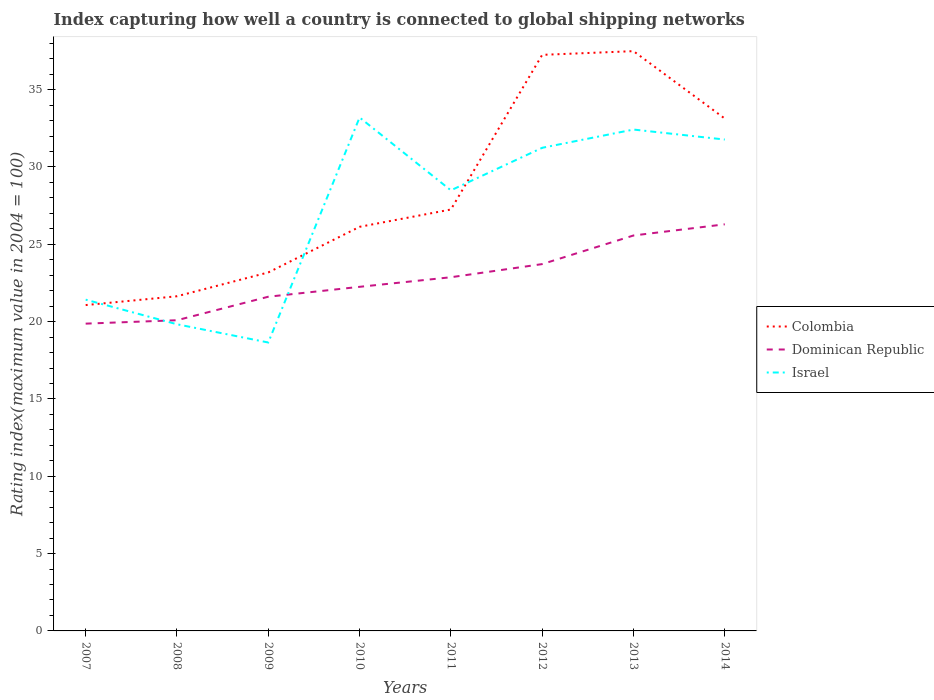Does the line corresponding to Dominican Republic intersect with the line corresponding to Israel?
Your answer should be compact. Yes. Across all years, what is the maximum rating index in Dominican Republic?
Offer a very short reply. 19.87. What is the total rating index in Israel in the graph?
Make the answer very short. -3.28. What is the difference between the highest and the second highest rating index in Dominican Republic?
Keep it short and to the point. 6.42. How many lines are there?
Your response must be concise. 3. How many years are there in the graph?
Your response must be concise. 8. How many legend labels are there?
Provide a short and direct response. 3. What is the title of the graph?
Offer a terse response. Index capturing how well a country is connected to global shipping networks. Does "Angola" appear as one of the legend labels in the graph?
Make the answer very short. No. What is the label or title of the Y-axis?
Provide a short and direct response. Rating index(maximum value in 2004 = 100). What is the Rating index(maximum value in 2004 = 100) in Colombia in 2007?
Ensure brevity in your answer.  21.07. What is the Rating index(maximum value in 2004 = 100) in Dominican Republic in 2007?
Offer a very short reply. 19.87. What is the Rating index(maximum value in 2004 = 100) in Israel in 2007?
Ensure brevity in your answer.  21.42. What is the Rating index(maximum value in 2004 = 100) of Colombia in 2008?
Give a very brief answer. 21.64. What is the Rating index(maximum value in 2004 = 100) in Dominican Republic in 2008?
Your answer should be compact. 20.09. What is the Rating index(maximum value in 2004 = 100) of Israel in 2008?
Offer a very short reply. 19.83. What is the Rating index(maximum value in 2004 = 100) of Colombia in 2009?
Offer a very short reply. 23.18. What is the Rating index(maximum value in 2004 = 100) in Dominican Republic in 2009?
Provide a succinct answer. 21.61. What is the Rating index(maximum value in 2004 = 100) in Israel in 2009?
Provide a short and direct response. 18.65. What is the Rating index(maximum value in 2004 = 100) in Colombia in 2010?
Provide a succinct answer. 26.13. What is the Rating index(maximum value in 2004 = 100) of Dominican Republic in 2010?
Provide a succinct answer. 22.25. What is the Rating index(maximum value in 2004 = 100) in Israel in 2010?
Make the answer very short. 33.2. What is the Rating index(maximum value in 2004 = 100) in Colombia in 2011?
Offer a terse response. 27.25. What is the Rating index(maximum value in 2004 = 100) of Dominican Republic in 2011?
Your answer should be compact. 22.87. What is the Rating index(maximum value in 2004 = 100) of Israel in 2011?
Your answer should be very brief. 28.49. What is the Rating index(maximum value in 2004 = 100) of Colombia in 2012?
Your answer should be very brief. 37.25. What is the Rating index(maximum value in 2004 = 100) in Dominican Republic in 2012?
Keep it short and to the point. 23.72. What is the Rating index(maximum value in 2004 = 100) of Israel in 2012?
Provide a short and direct response. 31.24. What is the Rating index(maximum value in 2004 = 100) of Colombia in 2013?
Provide a succinct answer. 37.49. What is the Rating index(maximum value in 2004 = 100) of Dominican Republic in 2013?
Ensure brevity in your answer.  25.57. What is the Rating index(maximum value in 2004 = 100) in Israel in 2013?
Provide a succinct answer. 32.42. What is the Rating index(maximum value in 2004 = 100) in Colombia in 2014?
Offer a terse response. 33.13. What is the Rating index(maximum value in 2004 = 100) in Dominican Republic in 2014?
Your answer should be very brief. 26.29. What is the Rating index(maximum value in 2004 = 100) of Israel in 2014?
Keep it short and to the point. 31.77. Across all years, what is the maximum Rating index(maximum value in 2004 = 100) of Colombia?
Provide a short and direct response. 37.49. Across all years, what is the maximum Rating index(maximum value in 2004 = 100) of Dominican Republic?
Ensure brevity in your answer.  26.29. Across all years, what is the maximum Rating index(maximum value in 2004 = 100) of Israel?
Provide a short and direct response. 33.2. Across all years, what is the minimum Rating index(maximum value in 2004 = 100) in Colombia?
Your response must be concise. 21.07. Across all years, what is the minimum Rating index(maximum value in 2004 = 100) of Dominican Republic?
Your answer should be compact. 19.87. Across all years, what is the minimum Rating index(maximum value in 2004 = 100) of Israel?
Your answer should be compact. 18.65. What is the total Rating index(maximum value in 2004 = 100) in Colombia in the graph?
Provide a short and direct response. 227.14. What is the total Rating index(maximum value in 2004 = 100) of Dominican Republic in the graph?
Keep it short and to the point. 182.27. What is the total Rating index(maximum value in 2004 = 100) in Israel in the graph?
Make the answer very short. 217.02. What is the difference between the Rating index(maximum value in 2004 = 100) in Colombia in 2007 and that in 2008?
Your response must be concise. -0.57. What is the difference between the Rating index(maximum value in 2004 = 100) of Dominican Republic in 2007 and that in 2008?
Offer a very short reply. -0.22. What is the difference between the Rating index(maximum value in 2004 = 100) in Israel in 2007 and that in 2008?
Keep it short and to the point. 1.59. What is the difference between the Rating index(maximum value in 2004 = 100) in Colombia in 2007 and that in 2009?
Provide a short and direct response. -2.11. What is the difference between the Rating index(maximum value in 2004 = 100) in Dominican Republic in 2007 and that in 2009?
Offer a very short reply. -1.74. What is the difference between the Rating index(maximum value in 2004 = 100) in Israel in 2007 and that in 2009?
Your response must be concise. 2.77. What is the difference between the Rating index(maximum value in 2004 = 100) in Colombia in 2007 and that in 2010?
Give a very brief answer. -5.06. What is the difference between the Rating index(maximum value in 2004 = 100) in Dominican Republic in 2007 and that in 2010?
Offer a very short reply. -2.38. What is the difference between the Rating index(maximum value in 2004 = 100) of Israel in 2007 and that in 2010?
Your answer should be very brief. -11.78. What is the difference between the Rating index(maximum value in 2004 = 100) in Colombia in 2007 and that in 2011?
Give a very brief answer. -6.18. What is the difference between the Rating index(maximum value in 2004 = 100) of Dominican Republic in 2007 and that in 2011?
Your answer should be very brief. -3. What is the difference between the Rating index(maximum value in 2004 = 100) in Israel in 2007 and that in 2011?
Offer a terse response. -7.07. What is the difference between the Rating index(maximum value in 2004 = 100) in Colombia in 2007 and that in 2012?
Ensure brevity in your answer.  -16.18. What is the difference between the Rating index(maximum value in 2004 = 100) in Dominican Republic in 2007 and that in 2012?
Provide a short and direct response. -3.85. What is the difference between the Rating index(maximum value in 2004 = 100) of Israel in 2007 and that in 2012?
Make the answer very short. -9.82. What is the difference between the Rating index(maximum value in 2004 = 100) in Colombia in 2007 and that in 2013?
Provide a succinct answer. -16.42. What is the difference between the Rating index(maximum value in 2004 = 100) in Dominican Republic in 2007 and that in 2013?
Your answer should be compact. -5.7. What is the difference between the Rating index(maximum value in 2004 = 100) in Israel in 2007 and that in 2013?
Ensure brevity in your answer.  -11. What is the difference between the Rating index(maximum value in 2004 = 100) of Colombia in 2007 and that in 2014?
Your answer should be very brief. -12.06. What is the difference between the Rating index(maximum value in 2004 = 100) in Dominican Republic in 2007 and that in 2014?
Offer a terse response. -6.42. What is the difference between the Rating index(maximum value in 2004 = 100) of Israel in 2007 and that in 2014?
Offer a very short reply. -10.35. What is the difference between the Rating index(maximum value in 2004 = 100) of Colombia in 2008 and that in 2009?
Keep it short and to the point. -1.54. What is the difference between the Rating index(maximum value in 2004 = 100) in Dominican Republic in 2008 and that in 2009?
Your answer should be compact. -1.52. What is the difference between the Rating index(maximum value in 2004 = 100) of Israel in 2008 and that in 2009?
Make the answer very short. 1.18. What is the difference between the Rating index(maximum value in 2004 = 100) of Colombia in 2008 and that in 2010?
Make the answer very short. -4.49. What is the difference between the Rating index(maximum value in 2004 = 100) of Dominican Republic in 2008 and that in 2010?
Make the answer very short. -2.16. What is the difference between the Rating index(maximum value in 2004 = 100) of Israel in 2008 and that in 2010?
Your response must be concise. -13.37. What is the difference between the Rating index(maximum value in 2004 = 100) in Colombia in 2008 and that in 2011?
Your answer should be very brief. -5.61. What is the difference between the Rating index(maximum value in 2004 = 100) of Dominican Republic in 2008 and that in 2011?
Your answer should be compact. -2.78. What is the difference between the Rating index(maximum value in 2004 = 100) in Israel in 2008 and that in 2011?
Your answer should be very brief. -8.66. What is the difference between the Rating index(maximum value in 2004 = 100) of Colombia in 2008 and that in 2012?
Ensure brevity in your answer.  -15.61. What is the difference between the Rating index(maximum value in 2004 = 100) of Dominican Republic in 2008 and that in 2012?
Your answer should be very brief. -3.63. What is the difference between the Rating index(maximum value in 2004 = 100) in Israel in 2008 and that in 2012?
Your response must be concise. -11.41. What is the difference between the Rating index(maximum value in 2004 = 100) in Colombia in 2008 and that in 2013?
Your answer should be very brief. -15.85. What is the difference between the Rating index(maximum value in 2004 = 100) of Dominican Republic in 2008 and that in 2013?
Make the answer very short. -5.48. What is the difference between the Rating index(maximum value in 2004 = 100) in Israel in 2008 and that in 2013?
Your answer should be compact. -12.59. What is the difference between the Rating index(maximum value in 2004 = 100) in Colombia in 2008 and that in 2014?
Give a very brief answer. -11.49. What is the difference between the Rating index(maximum value in 2004 = 100) in Dominican Republic in 2008 and that in 2014?
Give a very brief answer. -6.2. What is the difference between the Rating index(maximum value in 2004 = 100) in Israel in 2008 and that in 2014?
Offer a very short reply. -11.94. What is the difference between the Rating index(maximum value in 2004 = 100) in Colombia in 2009 and that in 2010?
Your answer should be compact. -2.95. What is the difference between the Rating index(maximum value in 2004 = 100) of Dominican Republic in 2009 and that in 2010?
Keep it short and to the point. -0.64. What is the difference between the Rating index(maximum value in 2004 = 100) in Israel in 2009 and that in 2010?
Offer a terse response. -14.55. What is the difference between the Rating index(maximum value in 2004 = 100) of Colombia in 2009 and that in 2011?
Give a very brief answer. -4.07. What is the difference between the Rating index(maximum value in 2004 = 100) in Dominican Republic in 2009 and that in 2011?
Ensure brevity in your answer.  -1.26. What is the difference between the Rating index(maximum value in 2004 = 100) of Israel in 2009 and that in 2011?
Make the answer very short. -9.84. What is the difference between the Rating index(maximum value in 2004 = 100) in Colombia in 2009 and that in 2012?
Provide a succinct answer. -14.07. What is the difference between the Rating index(maximum value in 2004 = 100) in Dominican Republic in 2009 and that in 2012?
Keep it short and to the point. -2.11. What is the difference between the Rating index(maximum value in 2004 = 100) in Israel in 2009 and that in 2012?
Ensure brevity in your answer.  -12.59. What is the difference between the Rating index(maximum value in 2004 = 100) in Colombia in 2009 and that in 2013?
Your answer should be very brief. -14.31. What is the difference between the Rating index(maximum value in 2004 = 100) in Dominican Republic in 2009 and that in 2013?
Make the answer very short. -3.96. What is the difference between the Rating index(maximum value in 2004 = 100) in Israel in 2009 and that in 2013?
Offer a terse response. -13.77. What is the difference between the Rating index(maximum value in 2004 = 100) of Colombia in 2009 and that in 2014?
Offer a very short reply. -9.95. What is the difference between the Rating index(maximum value in 2004 = 100) in Dominican Republic in 2009 and that in 2014?
Your answer should be compact. -4.68. What is the difference between the Rating index(maximum value in 2004 = 100) in Israel in 2009 and that in 2014?
Your answer should be very brief. -13.12. What is the difference between the Rating index(maximum value in 2004 = 100) of Colombia in 2010 and that in 2011?
Keep it short and to the point. -1.12. What is the difference between the Rating index(maximum value in 2004 = 100) of Dominican Republic in 2010 and that in 2011?
Make the answer very short. -0.62. What is the difference between the Rating index(maximum value in 2004 = 100) in Israel in 2010 and that in 2011?
Your answer should be compact. 4.71. What is the difference between the Rating index(maximum value in 2004 = 100) in Colombia in 2010 and that in 2012?
Keep it short and to the point. -11.12. What is the difference between the Rating index(maximum value in 2004 = 100) of Dominican Republic in 2010 and that in 2012?
Provide a succinct answer. -1.47. What is the difference between the Rating index(maximum value in 2004 = 100) in Israel in 2010 and that in 2012?
Your answer should be very brief. 1.96. What is the difference between the Rating index(maximum value in 2004 = 100) in Colombia in 2010 and that in 2013?
Offer a very short reply. -11.36. What is the difference between the Rating index(maximum value in 2004 = 100) of Dominican Republic in 2010 and that in 2013?
Ensure brevity in your answer.  -3.32. What is the difference between the Rating index(maximum value in 2004 = 100) of Israel in 2010 and that in 2013?
Make the answer very short. 0.78. What is the difference between the Rating index(maximum value in 2004 = 100) of Colombia in 2010 and that in 2014?
Give a very brief answer. -7. What is the difference between the Rating index(maximum value in 2004 = 100) of Dominican Republic in 2010 and that in 2014?
Ensure brevity in your answer.  -4.04. What is the difference between the Rating index(maximum value in 2004 = 100) in Israel in 2010 and that in 2014?
Your answer should be very brief. 1.43. What is the difference between the Rating index(maximum value in 2004 = 100) in Dominican Republic in 2011 and that in 2012?
Offer a terse response. -0.85. What is the difference between the Rating index(maximum value in 2004 = 100) in Israel in 2011 and that in 2012?
Give a very brief answer. -2.75. What is the difference between the Rating index(maximum value in 2004 = 100) of Colombia in 2011 and that in 2013?
Keep it short and to the point. -10.24. What is the difference between the Rating index(maximum value in 2004 = 100) in Dominican Republic in 2011 and that in 2013?
Provide a short and direct response. -2.7. What is the difference between the Rating index(maximum value in 2004 = 100) in Israel in 2011 and that in 2013?
Ensure brevity in your answer.  -3.93. What is the difference between the Rating index(maximum value in 2004 = 100) in Colombia in 2011 and that in 2014?
Your response must be concise. -5.88. What is the difference between the Rating index(maximum value in 2004 = 100) in Dominican Republic in 2011 and that in 2014?
Your answer should be compact. -3.42. What is the difference between the Rating index(maximum value in 2004 = 100) in Israel in 2011 and that in 2014?
Offer a terse response. -3.28. What is the difference between the Rating index(maximum value in 2004 = 100) of Colombia in 2012 and that in 2013?
Your response must be concise. -0.24. What is the difference between the Rating index(maximum value in 2004 = 100) in Dominican Republic in 2012 and that in 2013?
Offer a very short reply. -1.85. What is the difference between the Rating index(maximum value in 2004 = 100) in Israel in 2012 and that in 2013?
Provide a short and direct response. -1.18. What is the difference between the Rating index(maximum value in 2004 = 100) in Colombia in 2012 and that in 2014?
Ensure brevity in your answer.  4.12. What is the difference between the Rating index(maximum value in 2004 = 100) in Dominican Republic in 2012 and that in 2014?
Your answer should be very brief. -2.57. What is the difference between the Rating index(maximum value in 2004 = 100) of Israel in 2012 and that in 2014?
Keep it short and to the point. -0.53. What is the difference between the Rating index(maximum value in 2004 = 100) of Colombia in 2013 and that in 2014?
Your response must be concise. 4.36. What is the difference between the Rating index(maximum value in 2004 = 100) in Dominican Republic in 2013 and that in 2014?
Your answer should be compact. -0.72. What is the difference between the Rating index(maximum value in 2004 = 100) of Israel in 2013 and that in 2014?
Offer a very short reply. 0.65. What is the difference between the Rating index(maximum value in 2004 = 100) in Colombia in 2007 and the Rating index(maximum value in 2004 = 100) in Israel in 2008?
Provide a succinct answer. 1.24. What is the difference between the Rating index(maximum value in 2004 = 100) of Dominican Republic in 2007 and the Rating index(maximum value in 2004 = 100) of Israel in 2008?
Offer a terse response. 0.04. What is the difference between the Rating index(maximum value in 2004 = 100) in Colombia in 2007 and the Rating index(maximum value in 2004 = 100) in Dominican Republic in 2009?
Make the answer very short. -0.54. What is the difference between the Rating index(maximum value in 2004 = 100) of Colombia in 2007 and the Rating index(maximum value in 2004 = 100) of Israel in 2009?
Offer a terse response. 2.42. What is the difference between the Rating index(maximum value in 2004 = 100) of Dominican Republic in 2007 and the Rating index(maximum value in 2004 = 100) of Israel in 2009?
Provide a succinct answer. 1.22. What is the difference between the Rating index(maximum value in 2004 = 100) in Colombia in 2007 and the Rating index(maximum value in 2004 = 100) in Dominican Republic in 2010?
Make the answer very short. -1.18. What is the difference between the Rating index(maximum value in 2004 = 100) in Colombia in 2007 and the Rating index(maximum value in 2004 = 100) in Israel in 2010?
Your answer should be very brief. -12.13. What is the difference between the Rating index(maximum value in 2004 = 100) in Dominican Republic in 2007 and the Rating index(maximum value in 2004 = 100) in Israel in 2010?
Your answer should be compact. -13.33. What is the difference between the Rating index(maximum value in 2004 = 100) in Colombia in 2007 and the Rating index(maximum value in 2004 = 100) in Israel in 2011?
Your answer should be very brief. -7.42. What is the difference between the Rating index(maximum value in 2004 = 100) in Dominican Republic in 2007 and the Rating index(maximum value in 2004 = 100) in Israel in 2011?
Offer a very short reply. -8.62. What is the difference between the Rating index(maximum value in 2004 = 100) in Colombia in 2007 and the Rating index(maximum value in 2004 = 100) in Dominican Republic in 2012?
Your response must be concise. -2.65. What is the difference between the Rating index(maximum value in 2004 = 100) in Colombia in 2007 and the Rating index(maximum value in 2004 = 100) in Israel in 2012?
Provide a succinct answer. -10.17. What is the difference between the Rating index(maximum value in 2004 = 100) of Dominican Republic in 2007 and the Rating index(maximum value in 2004 = 100) of Israel in 2012?
Keep it short and to the point. -11.37. What is the difference between the Rating index(maximum value in 2004 = 100) of Colombia in 2007 and the Rating index(maximum value in 2004 = 100) of Dominican Republic in 2013?
Offer a terse response. -4.5. What is the difference between the Rating index(maximum value in 2004 = 100) in Colombia in 2007 and the Rating index(maximum value in 2004 = 100) in Israel in 2013?
Give a very brief answer. -11.35. What is the difference between the Rating index(maximum value in 2004 = 100) in Dominican Republic in 2007 and the Rating index(maximum value in 2004 = 100) in Israel in 2013?
Make the answer very short. -12.55. What is the difference between the Rating index(maximum value in 2004 = 100) in Colombia in 2007 and the Rating index(maximum value in 2004 = 100) in Dominican Republic in 2014?
Your answer should be very brief. -5.22. What is the difference between the Rating index(maximum value in 2004 = 100) in Colombia in 2007 and the Rating index(maximum value in 2004 = 100) in Israel in 2014?
Ensure brevity in your answer.  -10.7. What is the difference between the Rating index(maximum value in 2004 = 100) in Dominican Republic in 2007 and the Rating index(maximum value in 2004 = 100) in Israel in 2014?
Offer a very short reply. -11.9. What is the difference between the Rating index(maximum value in 2004 = 100) in Colombia in 2008 and the Rating index(maximum value in 2004 = 100) in Dominican Republic in 2009?
Make the answer very short. 0.03. What is the difference between the Rating index(maximum value in 2004 = 100) in Colombia in 2008 and the Rating index(maximum value in 2004 = 100) in Israel in 2009?
Offer a very short reply. 2.99. What is the difference between the Rating index(maximum value in 2004 = 100) in Dominican Republic in 2008 and the Rating index(maximum value in 2004 = 100) in Israel in 2009?
Provide a succinct answer. 1.44. What is the difference between the Rating index(maximum value in 2004 = 100) in Colombia in 2008 and the Rating index(maximum value in 2004 = 100) in Dominican Republic in 2010?
Offer a terse response. -0.61. What is the difference between the Rating index(maximum value in 2004 = 100) of Colombia in 2008 and the Rating index(maximum value in 2004 = 100) of Israel in 2010?
Keep it short and to the point. -11.56. What is the difference between the Rating index(maximum value in 2004 = 100) in Dominican Republic in 2008 and the Rating index(maximum value in 2004 = 100) in Israel in 2010?
Ensure brevity in your answer.  -13.11. What is the difference between the Rating index(maximum value in 2004 = 100) of Colombia in 2008 and the Rating index(maximum value in 2004 = 100) of Dominican Republic in 2011?
Offer a very short reply. -1.23. What is the difference between the Rating index(maximum value in 2004 = 100) in Colombia in 2008 and the Rating index(maximum value in 2004 = 100) in Israel in 2011?
Your response must be concise. -6.85. What is the difference between the Rating index(maximum value in 2004 = 100) of Dominican Republic in 2008 and the Rating index(maximum value in 2004 = 100) of Israel in 2011?
Provide a succinct answer. -8.4. What is the difference between the Rating index(maximum value in 2004 = 100) in Colombia in 2008 and the Rating index(maximum value in 2004 = 100) in Dominican Republic in 2012?
Ensure brevity in your answer.  -2.08. What is the difference between the Rating index(maximum value in 2004 = 100) in Dominican Republic in 2008 and the Rating index(maximum value in 2004 = 100) in Israel in 2012?
Your answer should be very brief. -11.15. What is the difference between the Rating index(maximum value in 2004 = 100) in Colombia in 2008 and the Rating index(maximum value in 2004 = 100) in Dominican Republic in 2013?
Provide a short and direct response. -3.93. What is the difference between the Rating index(maximum value in 2004 = 100) of Colombia in 2008 and the Rating index(maximum value in 2004 = 100) of Israel in 2013?
Your answer should be compact. -10.78. What is the difference between the Rating index(maximum value in 2004 = 100) of Dominican Republic in 2008 and the Rating index(maximum value in 2004 = 100) of Israel in 2013?
Ensure brevity in your answer.  -12.33. What is the difference between the Rating index(maximum value in 2004 = 100) in Colombia in 2008 and the Rating index(maximum value in 2004 = 100) in Dominican Republic in 2014?
Provide a short and direct response. -4.65. What is the difference between the Rating index(maximum value in 2004 = 100) of Colombia in 2008 and the Rating index(maximum value in 2004 = 100) of Israel in 2014?
Your response must be concise. -10.13. What is the difference between the Rating index(maximum value in 2004 = 100) in Dominican Republic in 2008 and the Rating index(maximum value in 2004 = 100) in Israel in 2014?
Offer a terse response. -11.68. What is the difference between the Rating index(maximum value in 2004 = 100) in Colombia in 2009 and the Rating index(maximum value in 2004 = 100) in Dominican Republic in 2010?
Provide a short and direct response. 0.93. What is the difference between the Rating index(maximum value in 2004 = 100) in Colombia in 2009 and the Rating index(maximum value in 2004 = 100) in Israel in 2010?
Your response must be concise. -10.02. What is the difference between the Rating index(maximum value in 2004 = 100) in Dominican Republic in 2009 and the Rating index(maximum value in 2004 = 100) in Israel in 2010?
Provide a succinct answer. -11.59. What is the difference between the Rating index(maximum value in 2004 = 100) in Colombia in 2009 and the Rating index(maximum value in 2004 = 100) in Dominican Republic in 2011?
Offer a terse response. 0.31. What is the difference between the Rating index(maximum value in 2004 = 100) of Colombia in 2009 and the Rating index(maximum value in 2004 = 100) of Israel in 2011?
Your answer should be very brief. -5.31. What is the difference between the Rating index(maximum value in 2004 = 100) in Dominican Republic in 2009 and the Rating index(maximum value in 2004 = 100) in Israel in 2011?
Your response must be concise. -6.88. What is the difference between the Rating index(maximum value in 2004 = 100) of Colombia in 2009 and the Rating index(maximum value in 2004 = 100) of Dominican Republic in 2012?
Give a very brief answer. -0.54. What is the difference between the Rating index(maximum value in 2004 = 100) in Colombia in 2009 and the Rating index(maximum value in 2004 = 100) in Israel in 2012?
Give a very brief answer. -8.06. What is the difference between the Rating index(maximum value in 2004 = 100) of Dominican Republic in 2009 and the Rating index(maximum value in 2004 = 100) of Israel in 2012?
Provide a succinct answer. -9.63. What is the difference between the Rating index(maximum value in 2004 = 100) in Colombia in 2009 and the Rating index(maximum value in 2004 = 100) in Dominican Republic in 2013?
Your answer should be compact. -2.39. What is the difference between the Rating index(maximum value in 2004 = 100) of Colombia in 2009 and the Rating index(maximum value in 2004 = 100) of Israel in 2013?
Give a very brief answer. -9.24. What is the difference between the Rating index(maximum value in 2004 = 100) of Dominican Republic in 2009 and the Rating index(maximum value in 2004 = 100) of Israel in 2013?
Provide a succinct answer. -10.81. What is the difference between the Rating index(maximum value in 2004 = 100) in Colombia in 2009 and the Rating index(maximum value in 2004 = 100) in Dominican Republic in 2014?
Your response must be concise. -3.11. What is the difference between the Rating index(maximum value in 2004 = 100) in Colombia in 2009 and the Rating index(maximum value in 2004 = 100) in Israel in 2014?
Give a very brief answer. -8.59. What is the difference between the Rating index(maximum value in 2004 = 100) of Dominican Republic in 2009 and the Rating index(maximum value in 2004 = 100) of Israel in 2014?
Provide a succinct answer. -10.16. What is the difference between the Rating index(maximum value in 2004 = 100) in Colombia in 2010 and the Rating index(maximum value in 2004 = 100) in Dominican Republic in 2011?
Offer a terse response. 3.26. What is the difference between the Rating index(maximum value in 2004 = 100) of Colombia in 2010 and the Rating index(maximum value in 2004 = 100) of Israel in 2011?
Your response must be concise. -2.36. What is the difference between the Rating index(maximum value in 2004 = 100) of Dominican Republic in 2010 and the Rating index(maximum value in 2004 = 100) of Israel in 2011?
Your answer should be very brief. -6.24. What is the difference between the Rating index(maximum value in 2004 = 100) of Colombia in 2010 and the Rating index(maximum value in 2004 = 100) of Dominican Republic in 2012?
Your response must be concise. 2.41. What is the difference between the Rating index(maximum value in 2004 = 100) in Colombia in 2010 and the Rating index(maximum value in 2004 = 100) in Israel in 2012?
Give a very brief answer. -5.11. What is the difference between the Rating index(maximum value in 2004 = 100) of Dominican Republic in 2010 and the Rating index(maximum value in 2004 = 100) of Israel in 2012?
Offer a very short reply. -8.99. What is the difference between the Rating index(maximum value in 2004 = 100) of Colombia in 2010 and the Rating index(maximum value in 2004 = 100) of Dominican Republic in 2013?
Your answer should be very brief. 0.56. What is the difference between the Rating index(maximum value in 2004 = 100) of Colombia in 2010 and the Rating index(maximum value in 2004 = 100) of Israel in 2013?
Your answer should be very brief. -6.29. What is the difference between the Rating index(maximum value in 2004 = 100) of Dominican Republic in 2010 and the Rating index(maximum value in 2004 = 100) of Israel in 2013?
Your answer should be very brief. -10.17. What is the difference between the Rating index(maximum value in 2004 = 100) of Colombia in 2010 and the Rating index(maximum value in 2004 = 100) of Dominican Republic in 2014?
Provide a succinct answer. -0.16. What is the difference between the Rating index(maximum value in 2004 = 100) of Colombia in 2010 and the Rating index(maximum value in 2004 = 100) of Israel in 2014?
Make the answer very short. -5.64. What is the difference between the Rating index(maximum value in 2004 = 100) in Dominican Republic in 2010 and the Rating index(maximum value in 2004 = 100) in Israel in 2014?
Ensure brevity in your answer.  -9.52. What is the difference between the Rating index(maximum value in 2004 = 100) in Colombia in 2011 and the Rating index(maximum value in 2004 = 100) in Dominican Republic in 2012?
Keep it short and to the point. 3.53. What is the difference between the Rating index(maximum value in 2004 = 100) of Colombia in 2011 and the Rating index(maximum value in 2004 = 100) of Israel in 2012?
Provide a succinct answer. -3.99. What is the difference between the Rating index(maximum value in 2004 = 100) of Dominican Republic in 2011 and the Rating index(maximum value in 2004 = 100) of Israel in 2012?
Provide a succinct answer. -8.37. What is the difference between the Rating index(maximum value in 2004 = 100) of Colombia in 2011 and the Rating index(maximum value in 2004 = 100) of Dominican Republic in 2013?
Provide a short and direct response. 1.68. What is the difference between the Rating index(maximum value in 2004 = 100) of Colombia in 2011 and the Rating index(maximum value in 2004 = 100) of Israel in 2013?
Your response must be concise. -5.17. What is the difference between the Rating index(maximum value in 2004 = 100) in Dominican Republic in 2011 and the Rating index(maximum value in 2004 = 100) in Israel in 2013?
Provide a short and direct response. -9.55. What is the difference between the Rating index(maximum value in 2004 = 100) in Colombia in 2011 and the Rating index(maximum value in 2004 = 100) in Dominican Republic in 2014?
Make the answer very short. 0.96. What is the difference between the Rating index(maximum value in 2004 = 100) of Colombia in 2011 and the Rating index(maximum value in 2004 = 100) of Israel in 2014?
Provide a short and direct response. -4.52. What is the difference between the Rating index(maximum value in 2004 = 100) in Dominican Republic in 2011 and the Rating index(maximum value in 2004 = 100) in Israel in 2014?
Provide a short and direct response. -8.9. What is the difference between the Rating index(maximum value in 2004 = 100) of Colombia in 2012 and the Rating index(maximum value in 2004 = 100) of Dominican Republic in 2013?
Provide a succinct answer. 11.68. What is the difference between the Rating index(maximum value in 2004 = 100) in Colombia in 2012 and the Rating index(maximum value in 2004 = 100) in Israel in 2013?
Provide a succinct answer. 4.83. What is the difference between the Rating index(maximum value in 2004 = 100) of Dominican Republic in 2012 and the Rating index(maximum value in 2004 = 100) of Israel in 2013?
Your answer should be very brief. -8.7. What is the difference between the Rating index(maximum value in 2004 = 100) in Colombia in 2012 and the Rating index(maximum value in 2004 = 100) in Dominican Republic in 2014?
Your answer should be compact. 10.96. What is the difference between the Rating index(maximum value in 2004 = 100) of Colombia in 2012 and the Rating index(maximum value in 2004 = 100) of Israel in 2014?
Your answer should be compact. 5.48. What is the difference between the Rating index(maximum value in 2004 = 100) in Dominican Republic in 2012 and the Rating index(maximum value in 2004 = 100) in Israel in 2014?
Your response must be concise. -8.05. What is the difference between the Rating index(maximum value in 2004 = 100) of Colombia in 2013 and the Rating index(maximum value in 2004 = 100) of Dominican Republic in 2014?
Ensure brevity in your answer.  11.2. What is the difference between the Rating index(maximum value in 2004 = 100) of Colombia in 2013 and the Rating index(maximum value in 2004 = 100) of Israel in 2014?
Give a very brief answer. 5.72. What is the difference between the Rating index(maximum value in 2004 = 100) in Dominican Republic in 2013 and the Rating index(maximum value in 2004 = 100) in Israel in 2014?
Keep it short and to the point. -6.2. What is the average Rating index(maximum value in 2004 = 100) in Colombia per year?
Your answer should be compact. 28.39. What is the average Rating index(maximum value in 2004 = 100) of Dominican Republic per year?
Make the answer very short. 22.78. What is the average Rating index(maximum value in 2004 = 100) of Israel per year?
Give a very brief answer. 27.13. In the year 2007, what is the difference between the Rating index(maximum value in 2004 = 100) of Colombia and Rating index(maximum value in 2004 = 100) of Dominican Republic?
Provide a succinct answer. 1.2. In the year 2007, what is the difference between the Rating index(maximum value in 2004 = 100) of Colombia and Rating index(maximum value in 2004 = 100) of Israel?
Provide a short and direct response. -0.35. In the year 2007, what is the difference between the Rating index(maximum value in 2004 = 100) in Dominican Republic and Rating index(maximum value in 2004 = 100) in Israel?
Offer a very short reply. -1.55. In the year 2008, what is the difference between the Rating index(maximum value in 2004 = 100) of Colombia and Rating index(maximum value in 2004 = 100) of Dominican Republic?
Keep it short and to the point. 1.55. In the year 2008, what is the difference between the Rating index(maximum value in 2004 = 100) in Colombia and Rating index(maximum value in 2004 = 100) in Israel?
Your answer should be very brief. 1.81. In the year 2008, what is the difference between the Rating index(maximum value in 2004 = 100) in Dominican Republic and Rating index(maximum value in 2004 = 100) in Israel?
Offer a very short reply. 0.26. In the year 2009, what is the difference between the Rating index(maximum value in 2004 = 100) of Colombia and Rating index(maximum value in 2004 = 100) of Dominican Republic?
Your response must be concise. 1.57. In the year 2009, what is the difference between the Rating index(maximum value in 2004 = 100) of Colombia and Rating index(maximum value in 2004 = 100) of Israel?
Provide a succinct answer. 4.53. In the year 2009, what is the difference between the Rating index(maximum value in 2004 = 100) in Dominican Republic and Rating index(maximum value in 2004 = 100) in Israel?
Offer a very short reply. 2.96. In the year 2010, what is the difference between the Rating index(maximum value in 2004 = 100) of Colombia and Rating index(maximum value in 2004 = 100) of Dominican Republic?
Ensure brevity in your answer.  3.88. In the year 2010, what is the difference between the Rating index(maximum value in 2004 = 100) of Colombia and Rating index(maximum value in 2004 = 100) of Israel?
Keep it short and to the point. -7.07. In the year 2010, what is the difference between the Rating index(maximum value in 2004 = 100) in Dominican Republic and Rating index(maximum value in 2004 = 100) in Israel?
Provide a short and direct response. -10.95. In the year 2011, what is the difference between the Rating index(maximum value in 2004 = 100) in Colombia and Rating index(maximum value in 2004 = 100) in Dominican Republic?
Give a very brief answer. 4.38. In the year 2011, what is the difference between the Rating index(maximum value in 2004 = 100) of Colombia and Rating index(maximum value in 2004 = 100) of Israel?
Make the answer very short. -1.24. In the year 2011, what is the difference between the Rating index(maximum value in 2004 = 100) of Dominican Republic and Rating index(maximum value in 2004 = 100) of Israel?
Make the answer very short. -5.62. In the year 2012, what is the difference between the Rating index(maximum value in 2004 = 100) in Colombia and Rating index(maximum value in 2004 = 100) in Dominican Republic?
Offer a terse response. 13.53. In the year 2012, what is the difference between the Rating index(maximum value in 2004 = 100) of Colombia and Rating index(maximum value in 2004 = 100) of Israel?
Provide a succinct answer. 6.01. In the year 2012, what is the difference between the Rating index(maximum value in 2004 = 100) in Dominican Republic and Rating index(maximum value in 2004 = 100) in Israel?
Offer a very short reply. -7.52. In the year 2013, what is the difference between the Rating index(maximum value in 2004 = 100) of Colombia and Rating index(maximum value in 2004 = 100) of Dominican Republic?
Provide a short and direct response. 11.92. In the year 2013, what is the difference between the Rating index(maximum value in 2004 = 100) in Colombia and Rating index(maximum value in 2004 = 100) in Israel?
Ensure brevity in your answer.  5.07. In the year 2013, what is the difference between the Rating index(maximum value in 2004 = 100) in Dominican Republic and Rating index(maximum value in 2004 = 100) in Israel?
Make the answer very short. -6.85. In the year 2014, what is the difference between the Rating index(maximum value in 2004 = 100) of Colombia and Rating index(maximum value in 2004 = 100) of Dominican Republic?
Your response must be concise. 6.84. In the year 2014, what is the difference between the Rating index(maximum value in 2004 = 100) in Colombia and Rating index(maximum value in 2004 = 100) in Israel?
Your answer should be compact. 1.36. In the year 2014, what is the difference between the Rating index(maximum value in 2004 = 100) in Dominican Republic and Rating index(maximum value in 2004 = 100) in Israel?
Your answer should be compact. -5.48. What is the ratio of the Rating index(maximum value in 2004 = 100) in Colombia in 2007 to that in 2008?
Offer a terse response. 0.97. What is the ratio of the Rating index(maximum value in 2004 = 100) in Dominican Republic in 2007 to that in 2008?
Provide a succinct answer. 0.99. What is the ratio of the Rating index(maximum value in 2004 = 100) of Israel in 2007 to that in 2008?
Keep it short and to the point. 1.08. What is the ratio of the Rating index(maximum value in 2004 = 100) in Colombia in 2007 to that in 2009?
Your response must be concise. 0.91. What is the ratio of the Rating index(maximum value in 2004 = 100) of Dominican Republic in 2007 to that in 2009?
Provide a short and direct response. 0.92. What is the ratio of the Rating index(maximum value in 2004 = 100) in Israel in 2007 to that in 2009?
Your response must be concise. 1.15. What is the ratio of the Rating index(maximum value in 2004 = 100) in Colombia in 2007 to that in 2010?
Offer a terse response. 0.81. What is the ratio of the Rating index(maximum value in 2004 = 100) in Dominican Republic in 2007 to that in 2010?
Your answer should be very brief. 0.89. What is the ratio of the Rating index(maximum value in 2004 = 100) in Israel in 2007 to that in 2010?
Your answer should be very brief. 0.65. What is the ratio of the Rating index(maximum value in 2004 = 100) of Colombia in 2007 to that in 2011?
Ensure brevity in your answer.  0.77. What is the ratio of the Rating index(maximum value in 2004 = 100) of Dominican Republic in 2007 to that in 2011?
Give a very brief answer. 0.87. What is the ratio of the Rating index(maximum value in 2004 = 100) of Israel in 2007 to that in 2011?
Provide a short and direct response. 0.75. What is the ratio of the Rating index(maximum value in 2004 = 100) of Colombia in 2007 to that in 2012?
Offer a terse response. 0.57. What is the ratio of the Rating index(maximum value in 2004 = 100) of Dominican Republic in 2007 to that in 2012?
Your answer should be very brief. 0.84. What is the ratio of the Rating index(maximum value in 2004 = 100) of Israel in 2007 to that in 2012?
Ensure brevity in your answer.  0.69. What is the ratio of the Rating index(maximum value in 2004 = 100) of Colombia in 2007 to that in 2013?
Make the answer very short. 0.56. What is the ratio of the Rating index(maximum value in 2004 = 100) in Dominican Republic in 2007 to that in 2013?
Keep it short and to the point. 0.78. What is the ratio of the Rating index(maximum value in 2004 = 100) of Israel in 2007 to that in 2013?
Your answer should be compact. 0.66. What is the ratio of the Rating index(maximum value in 2004 = 100) in Colombia in 2007 to that in 2014?
Make the answer very short. 0.64. What is the ratio of the Rating index(maximum value in 2004 = 100) in Dominican Republic in 2007 to that in 2014?
Give a very brief answer. 0.76. What is the ratio of the Rating index(maximum value in 2004 = 100) in Israel in 2007 to that in 2014?
Your answer should be compact. 0.67. What is the ratio of the Rating index(maximum value in 2004 = 100) in Colombia in 2008 to that in 2009?
Provide a short and direct response. 0.93. What is the ratio of the Rating index(maximum value in 2004 = 100) of Dominican Republic in 2008 to that in 2009?
Ensure brevity in your answer.  0.93. What is the ratio of the Rating index(maximum value in 2004 = 100) of Israel in 2008 to that in 2009?
Your response must be concise. 1.06. What is the ratio of the Rating index(maximum value in 2004 = 100) of Colombia in 2008 to that in 2010?
Provide a short and direct response. 0.83. What is the ratio of the Rating index(maximum value in 2004 = 100) in Dominican Republic in 2008 to that in 2010?
Your answer should be very brief. 0.9. What is the ratio of the Rating index(maximum value in 2004 = 100) in Israel in 2008 to that in 2010?
Your answer should be very brief. 0.6. What is the ratio of the Rating index(maximum value in 2004 = 100) in Colombia in 2008 to that in 2011?
Ensure brevity in your answer.  0.79. What is the ratio of the Rating index(maximum value in 2004 = 100) of Dominican Republic in 2008 to that in 2011?
Ensure brevity in your answer.  0.88. What is the ratio of the Rating index(maximum value in 2004 = 100) in Israel in 2008 to that in 2011?
Give a very brief answer. 0.7. What is the ratio of the Rating index(maximum value in 2004 = 100) in Colombia in 2008 to that in 2012?
Your answer should be compact. 0.58. What is the ratio of the Rating index(maximum value in 2004 = 100) in Dominican Republic in 2008 to that in 2012?
Your response must be concise. 0.85. What is the ratio of the Rating index(maximum value in 2004 = 100) in Israel in 2008 to that in 2012?
Keep it short and to the point. 0.63. What is the ratio of the Rating index(maximum value in 2004 = 100) of Colombia in 2008 to that in 2013?
Keep it short and to the point. 0.58. What is the ratio of the Rating index(maximum value in 2004 = 100) in Dominican Republic in 2008 to that in 2013?
Provide a succinct answer. 0.79. What is the ratio of the Rating index(maximum value in 2004 = 100) of Israel in 2008 to that in 2013?
Your response must be concise. 0.61. What is the ratio of the Rating index(maximum value in 2004 = 100) in Colombia in 2008 to that in 2014?
Offer a terse response. 0.65. What is the ratio of the Rating index(maximum value in 2004 = 100) in Dominican Republic in 2008 to that in 2014?
Provide a succinct answer. 0.76. What is the ratio of the Rating index(maximum value in 2004 = 100) of Israel in 2008 to that in 2014?
Offer a very short reply. 0.62. What is the ratio of the Rating index(maximum value in 2004 = 100) of Colombia in 2009 to that in 2010?
Give a very brief answer. 0.89. What is the ratio of the Rating index(maximum value in 2004 = 100) in Dominican Republic in 2009 to that in 2010?
Offer a terse response. 0.97. What is the ratio of the Rating index(maximum value in 2004 = 100) of Israel in 2009 to that in 2010?
Your response must be concise. 0.56. What is the ratio of the Rating index(maximum value in 2004 = 100) in Colombia in 2009 to that in 2011?
Offer a very short reply. 0.85. What is the ratio of the Rating index(maximum value in 2004 = 100) in Dominican Republic in 2009 to that in 2011?
Provide a short and direct response. 0.94. What is the ratio of the Rating index(maximum value in 2004 = 100) of Israel in 2009 to that in 2011?
Give a very brief answer. 0.65. What is the ratio of the Rating index(maximum value in 2004 = 100) in Colombia in 2009 to that in 2012?
Your response must be concise. 0.62. What is the ratio of the Rating index(maximum value in 2004 = 100) of Dominican Republic in 2009 to that in 2012?
Provide a succinct answer. 0.91. What is the ratio of the Rating index(maximum value in 2004 = 100) in Israel in 2009 to that in 2012?
Offer a very short reply. 0.6. What is the ratio of the Rating index(maximum value in 2004 = 100) of Colombia in 2009 to that in 2013?
Provide a short and direct response. 0.62. What is the ratio of the Rating index(maximum value in 2004 = 100) of Dominican Republic in 2009 to that in 2013?
Offer a very short reply. 0.85. What is the ratio of the Rating index(maximum value in 2004 = 100) of Israel in 2009 to that in 2013?
Make the answer very short. 0.58. What is the ratio of the Rating index(maximum value in 2004 = 100) in Colombia in 2009 to that in 2014?
Your answer should be compact. 0.7. What is the ratio of the Rating index(maximum value in 2004 = 100) in Dominican Republic in 2009 to that in 2014?
Offer a terse response. 0.82. What is the ratio of the Rating index(maximum value in 2004 = 100) in Israel in 2009 to that in 2014?
Make the answer very short. 0.59. What is the ratio of the Rating index(maximum value in 2004 = 100) in Colombia in 2010 to that in 2011?
Keep it short and to the point. 0.96. What is the ratio of the Rating index(maximum value in 2004 = 100) in Dominican Republic in 2010 to that in 2011?
Ensure brevity in your answer.  0.97. What is the ratio of the Rating index(maximum value in 2004 = 100) in Israel in 2010 to that in 2011?
Provide a succinct answer. 1.17. What is the ratio of the Rating index(maximum value in 2004 = 100) in Colombia in 2010 to that in 2012?
Your response must be concise. 0.7. What is the ratio of the Rating index(maximum value in 2004 = 100) in Dominican Republic in 2010 to that in 2012?
Your answer should be compact. 0.94. What is the ratio of the Rating index(maximum value in 2004 = 100) of Israel in 2010 to that in 2012?
Give a very brief answer. 1.06. What is the ratio of the Rating index(maximum value in 2004 = 100) in Colombia in 2010 to that in 2013?
Make the answer very short. 0.7. What is the ratio of the Rating index(maximum value in 2004 = 100) of Dominican Republic in 2010 to that in 2013?
Offer a terse response. 0.87. What is the ratio of the Rating index(maximum value in 2004 = 100) of Israel in 2010 to that in 2013?
Make the answer very short. 1.02. What is the ratio of the Rating index(maximum value in 2004 = 100) in Colombia in 2010 to that in 2014?
Provide a short and direct response. 0.79. What is the ratio of the Rating index(maximum value in 2004 = 100) of Dominican Republic in 2010 to that in 2014?
Provide a short and direct response. 0.85. What is the ratio of the Rating index(maximum value in 2004 = 100) in Israel in 2010 to that in 2014?
Give a very brief answer. 1.04. What is the ratio of the Rating index(maximum value in 2004 = 100) in Colombia in 2011 to that in 2012?
Offer a very short reply. 0.73. What is the ratio of the Rating index(maximum value in 2004 = 100) in Dominican Republic in 2011 to that in 2012?
Offer a very short reply. 0.96. What is the ratio of the Rating index(maximum value in 2004 = 100) of Israel in 2011 to that in 2012?
Provide a succinct answer. 0.91. What is the ratio of the Rating index(maximum value in 2004 = 100) of Colombia in 2011 to that in 2013?
Your response must be concise. 0.73. What is the ratio of the Rating index(maximum value in 2004 = 100) of Dominican Republic in 2011 to that in 2013?
Offer a terse response. 0.89. What is the ratio of the Rating index(maximum value in 2004 = 100) of Israel in 2011 to that in 2013?
Your answer should be very brief. 0.88. What is the ratio of the Rating index(maximum value in 2004 = 100) of Colombia in 2011 to that in 2014?
Ensure brevity in your answer.  0.82. What is the ratio of the Rating index(maximum value in 2004 = 100) in Dominican Republic in 2011 to that in 2014?
Make the answer very short. 0.87. What is the ratio of the Rating index(maximum value in 2004 = 100) in Israel in 2011 to that in 2014?
Ensure brevity in your answer.  0.9. What is the ratio of the Rating index(maximum value in 2004 = 100) in Colombia in 2012 to that in 2013?
Offer a very short reply. 0.99. What is the ratio of the Rating index(maximum value in 2004 = 100) in Dominican Republic in 2012 to that in 2013?
Ensure brevity in your answer.  0.93. What is the ratio of the Rating index(maximum value in 2004 = 100) of Israel in 2012 to that in 2013?
Ensure brevity in your answer.  0.96. What is the ratio of the Rating index(maximum value in 2004 = 100) of Colombia in 2012 to that in 2014?
Provide a succinct answer. 1.12. What is the ratio of the Rating index(maximum value in 2004 = 100) of Dominican Republic in 2012 to that in 2014?
Your answer should be very brief. 0.9. What is the ratio of the Rating index(maximum value in 2004 = 100) in Israel in 2012 to that in 2014?
Provide a succinct answer. 0.98. What is the ratio of the Rating index(maximum value in 2004 = 100) in Colombia in 2013 to that in 2014?
Provide a short and direct response. 1.13. What is the ratio of the Rating index(maximum value in 2004 = 100) of Dominican Republic in 2013 to that in 2014?
Provide a short and direct response. 0.97. What is the ratio of the Rating index(maximum value in 2004 = 100) in Israel in 2013 to that in 2014?
Ensure brevity in your answer.  1.02. What is the difference between the highest and the second highest Rating index(maximum value in 2004 = 100) of Colombia?
Offer a very short reply. 0.24. What is the difference between the highest and the second highest Rating index(maximum value in 2004 = 100) of Dominican Republic?
Your response must be concise. 0.72. What is the difference between the highest and the second highest Rating index(maximum value in 2004 = 100) in Israel?
Provide a succinct answer. 0.78. What is the difference between the highest and the lowest Rating index(maximum value in 2004 = 100) of Colombia?
Ensure brevity in your answer.  16.42. What is the difference between the highest and the lowest Rating index(maximum value in 2004 = 100) in Dominican Republic?
Ensure brevity in your answer.  6.42. What is the difference between the highest and the lowest Rating index(maximum value in 2004 = 100) in Israel?
Keep it short and to the point. 14.55. 